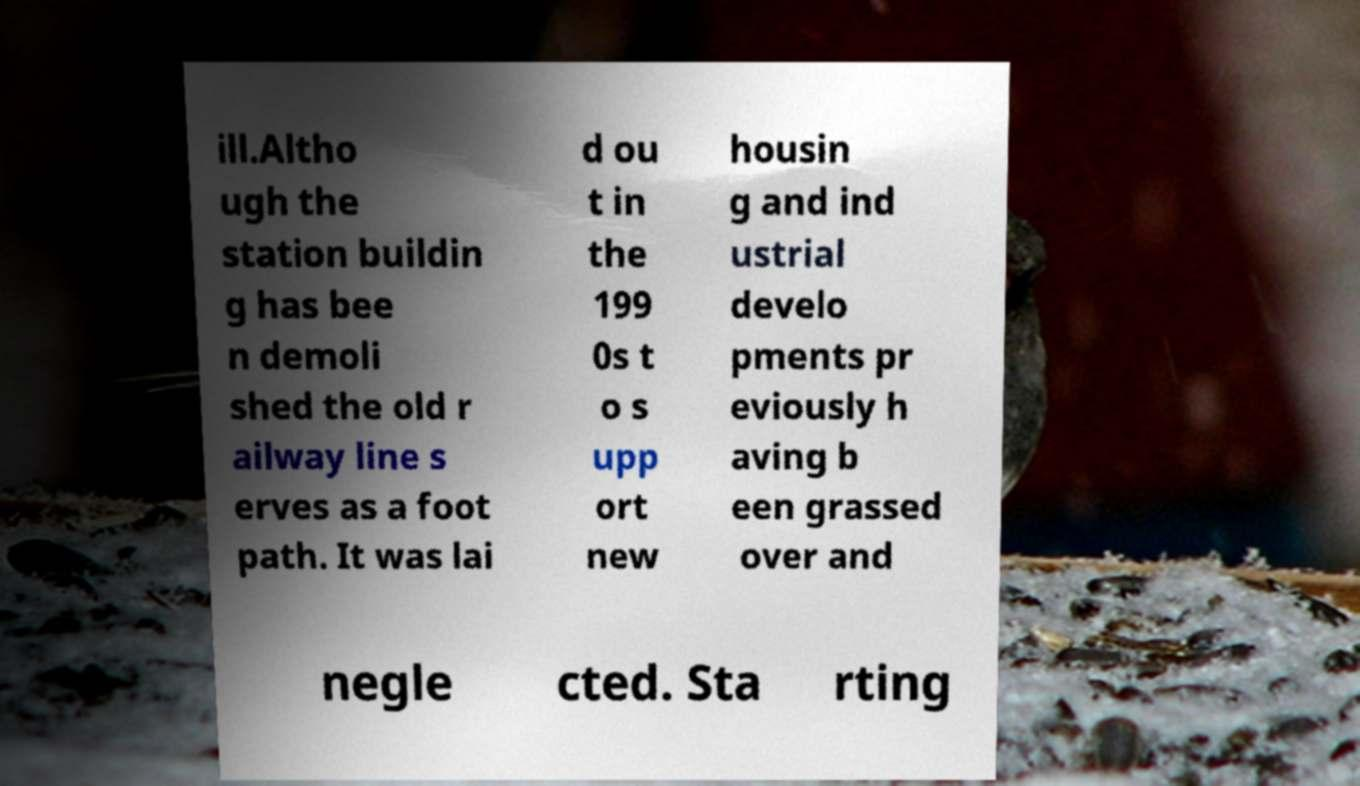Please identify and transcribe the text found in this image. ill.Altho ugh the station buildin g has bee n demoli shed the old r ailway line s erves as a foot path. It was lai d ou t in the 199 0s t o s upp ort new housin g and ind ustrial develo pments pr eviously h aving b een grassed over and negle cted. Sta rting 